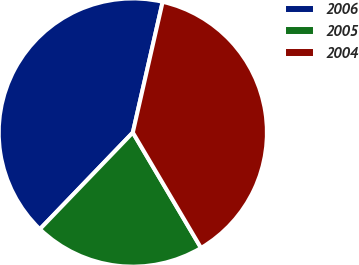<chart> <loc_0><loc_0><loc_500><loc_500><pie_chart><fcel>2006<fcel>2005<fcel>2004<nl><fcel>41.38%<fcel>20.69%<fcel>37.93%<nl></chart> 